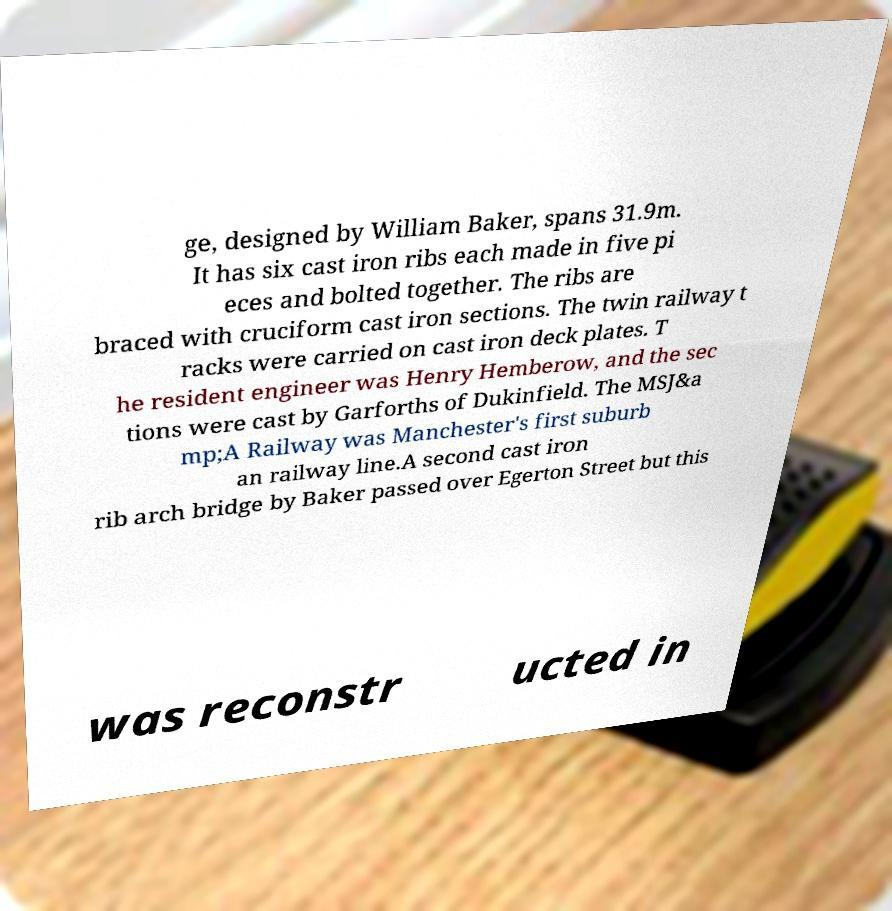Could you assist in decoding the text presented in this image and type it out clearly? ge, designed by William Baker, spans 31.9m. It has six cast iron ribs each made in five pi eces and bolted together. The ribs are braced with cruciform cast iron sections. The twin railway t racks were carried on cast iron deck plates. T he resident engineer was Henry Hemberow, and the sec tions were cast by Garforths of Dukinfield. The MSJ&a mp;A Railway was Manchester's first suburb an railway line.A second cast iron rib arch bridge by Baker passed over Egerton Street but this was reconstr ucted in 